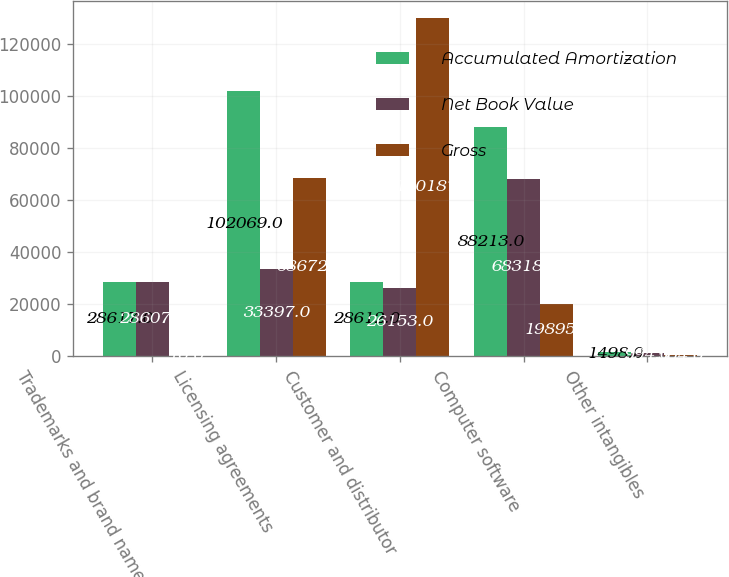Convert chart to OTSL. <chart><loc_0><loc_0><loc_500><loc_500><stacked_bar_chart><ecel><fcel>Trademarks and brand names<fcel>Licensing agreements<fcel>Customer and distributor<fcel>Computer software<fcel>Other intangibles<nl><fcel>Accumulated Amortization<fcel>28617<fcel>102069<fcel>28612<fcel>88213<fcel>1498<nl><fcel>Net Book Value<fcel>28607<fcel>33397<fcel>26153<fcel>68318<fcel>994<nl><fcel>Gross<fcel>10<fcel>68672<fcel>130187<fcel>19895<fcel>504<nl></chart> 